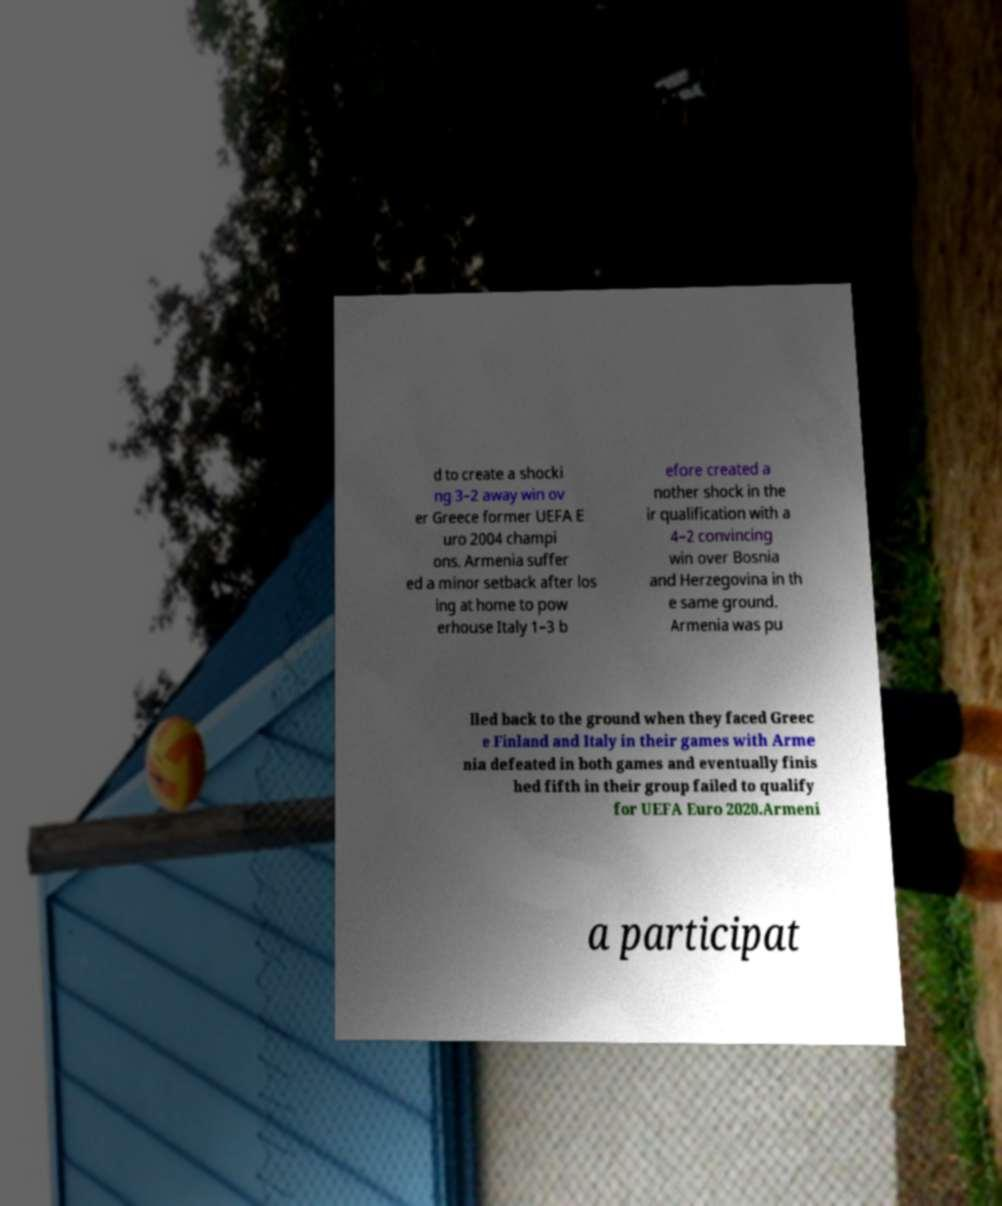Please identify and transcribe the text found in this image. d to create a shocki ng 3–2 away win ov er Greece former UEFA E uro 2004 champi ons. Armenia suffer ed a minor setback after los ing at home to pow erhouse Italy 1–3 b efore created a nother shock in the ir qualification with a 4–2 convincing win over Bosnia and Herzegovina in th e same ground. Armenia was pu lled back to the ground when they faced Greec e Finland and Italy in their games with Arme nia defeated in both games and eventually finis hed fifth in their group failed to qualify for UEFA Euro 2020.Armeni a participat 